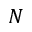Convert formula to latex. <formula><loc_0><loc_0><loc_500><loc_500>N</formula> 